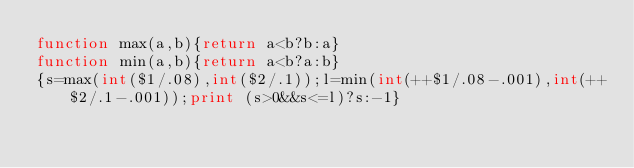<code> <loc_0><loc_0><loc_500><loc_500><_Awk_>function max(a,b){return a<b?b:a}
function min(a,b){return a<b?a:b}
{s=max(int($1/.08),int($2/.1));l=min(int(++$1/.08-.001),int(++$2/.1-.001));print (s>0&&s<=l)?s:-1}</code> 